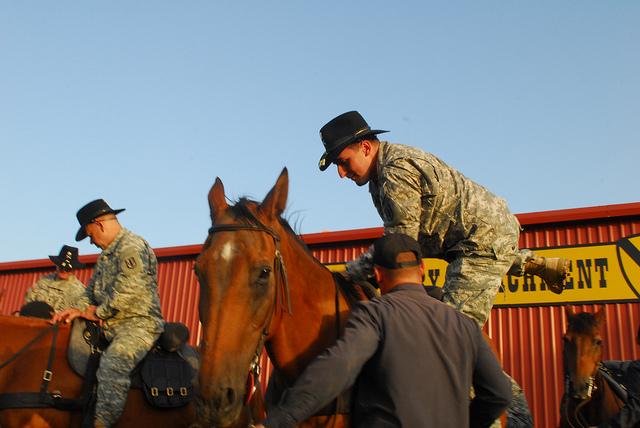What does the yellow banner say?
Quick response, please. Can't read. Are all of the humans in this picture wearing hats?
Quick response, please. Yes. Are these men soldiers?
Quick response, please. Yes. 